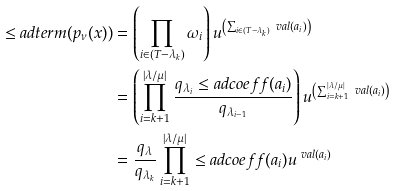Convert formula to latex. <formula><loc_0><loc_0><loc_500><loc_500>\leq a d t e r m ( p _ { \nu } ( x ) ) & = \left ( \prod _ { i \in ( T - \lambda _ { k } ) } \omega _ { i } \right ) u ^ { \left ( \sum _ { i \in ( T { - } \lambda _ { k } ) } \ v a l ( a _ { i } ) \right ) } \\ & = \left ( \prod _ { i = k + 1 } ^ { | \lambda / \mu | } \frac { q _ { \lambda _ { i } } \leq a d c o e f f ( a _ { i } ) } { q _ { \lambda _ { i - 1 } } } \right ) u ^ { \left ( \sum _ { i = k + 1 } ^ { | \lambda / \mu | } \ v a l ( a _ { i } ) \right ) } \\ & = \frac { q _ { \lambda } } { q _ { \lambda _ { k } } } \prod _ { i = k + 1 } ^ { | \lambda / \mu | } \leq a d c o e f f ( a _ { i } ) u ^ { \ v a l ( a _ { i } ) }</formula> 